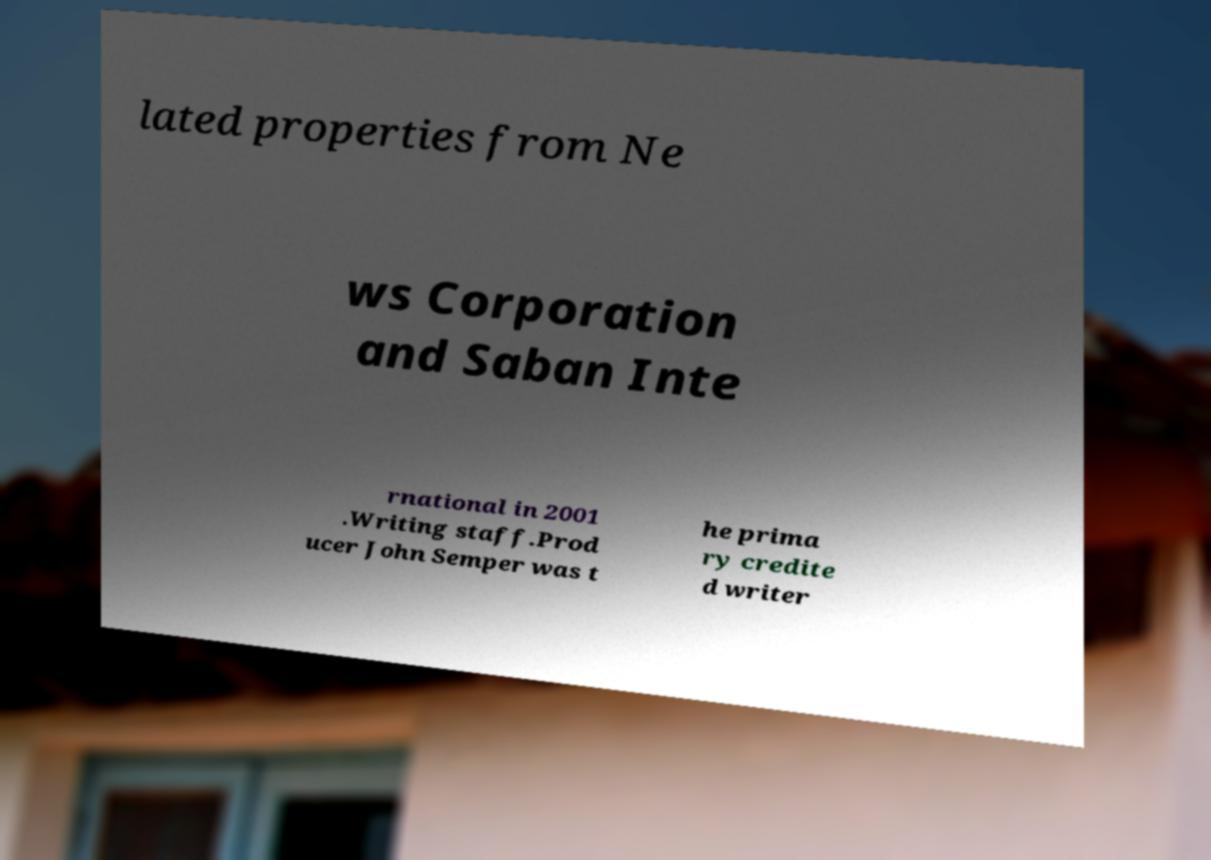Please read and relay the text visible in this image. What does it say? lated properties from Ne ws Corporation and Saban Inte rnational in 2001 .Writing staff.Prod ucer John Semper was t he prima ry credite d writer 